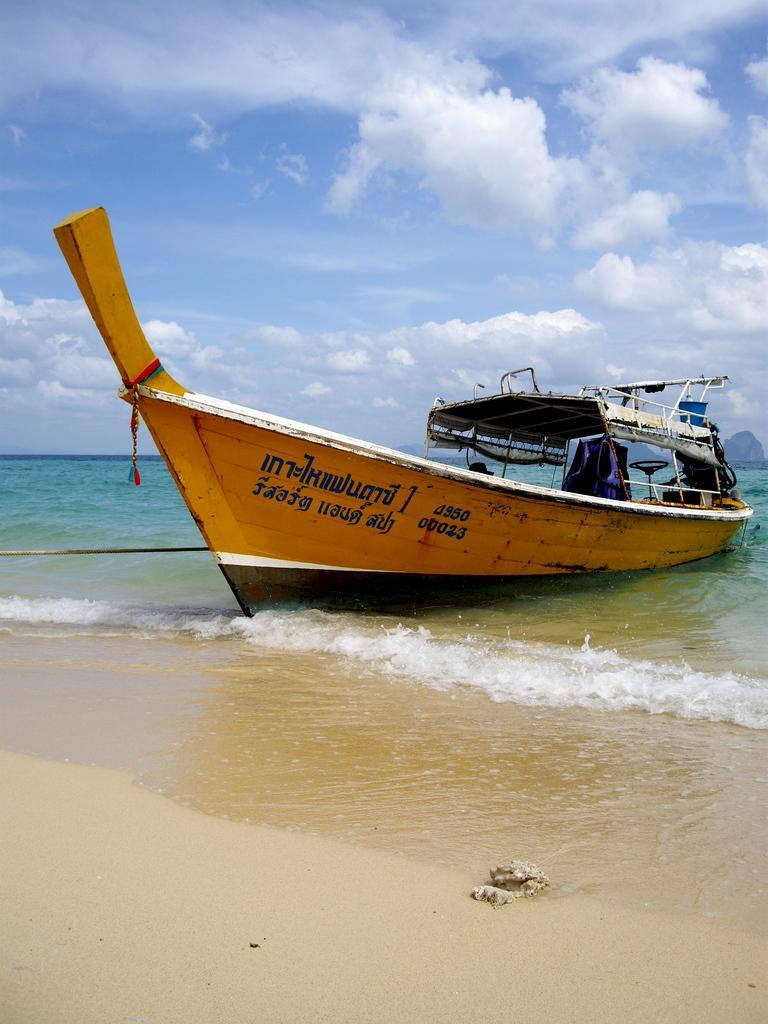Describe this image in one or two sentences. In this image I see the sand and I see boat over here which is of white, orange and brown in color and I see something is written over here and I see the water. In the background I see the clear sky. 